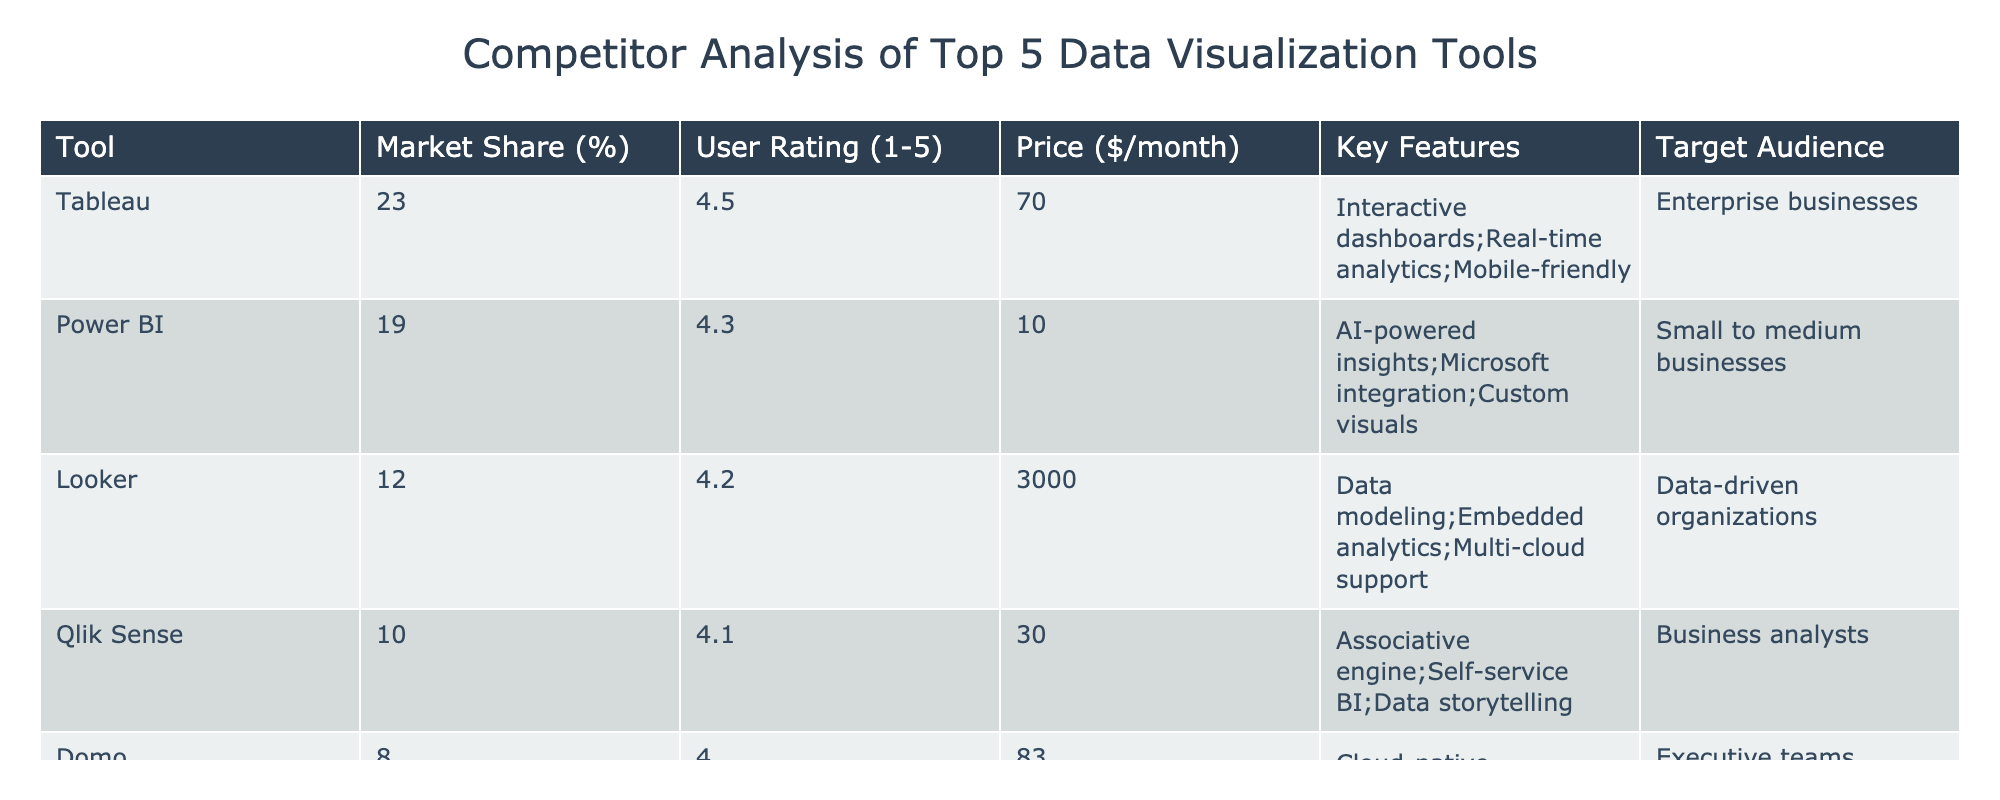What is the market share of Tableau? The table indicates that Tableau has a market share of 23%. Thus, it can be directly extracted from the Market Share column corresponding to Tableau.
Answer: 23% Which tool has the highest user rating? By analyzing the User Rating column, Tableau has the highest rating at 4.5, which is greater than the ratings of all other tools in the list.
Answer: Tableau What is the price difference between Looker and Power BI? The price of Looker is $3000 per month, while Power BI costs $10 per month. Calculating the difference: 3000 - 10 = 2990, so the difference is $2990.
Answer: 2990 Is Domo targeted towards enterprise businesses? The table indicates that Domo targets executive teams, which is different from the enterprise business focus. Therefore, the answer is no.
Answer: No What is the average user rating of the tools listed? The user ratings are 4.5 (Tableau), 4.3 (Power BI), 4.2 (Looker), 4.1 (Qlik Sense), and 4.0 (Domo). The total rating is 4.5 + 4.3 + 4.2 + 4.1 + 4.0 = 21. The average is 21 divided by 5, which equals 4.2.
Answer: 4.2 Which tool has the lowest price, and what is it? Observing the Price column, Power BI has the lowest price at $10 per month, which can be easily identified compared to the other prices listed.
Answer: Power BI, $10 Are all tools suitable for data-driven organizations? The target audience for Looker is specifically data-driven organizations, while others have different focuses, so not all tools are suitable for that specific audience.
Answer: No What key features does Power BI offer that stands out compared to others? Power BI offers AI-powered insights, Microsoft integration, and custom visuals, which can be compared with features of other tools to assess its uniqueness. This can be seen in the Key Features column.
Answer: AI-powered insights, Microsoft integration, custom visuals Which tool offers the most key features listed? Looking closely at the Key Features column, Tableau has three major features listed, more than others. While the feature count is equal between certain tools, Tableau stands out in overall relevance in an enterprise context.
Answer: Tableau 